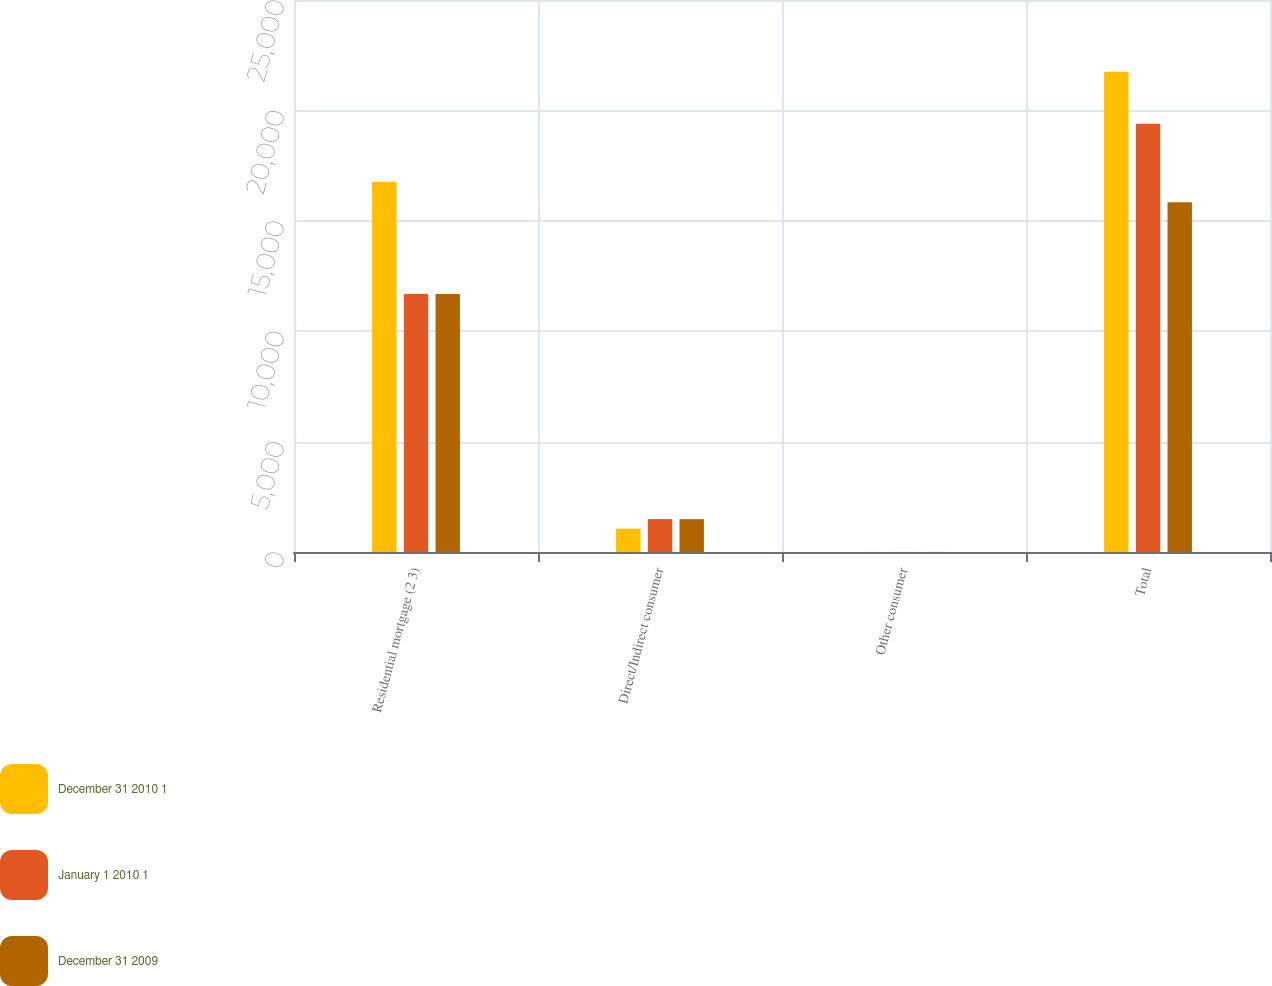Convert chart. <chart><loc_0><loc_0><loc_500><loc_500><stacked_bar_chart><ecel><fcel>Residential mortgage (2 3)<fcel>Direct/Indirect consumer<fcel>Other consumer<fcel>Total<nl><fcel>December 31 2010 1<fcel>16768<fcel>1058<fcel>2<fcel>21747<nl><fcel>January 1 2010 1<fcel>11680<fcel>1492<fcel>3<fcel>19397<nl><fcel>December 31 2009<fcel>11680<fcel>1488<fcel>3<fcel>15844<nl></chart> 